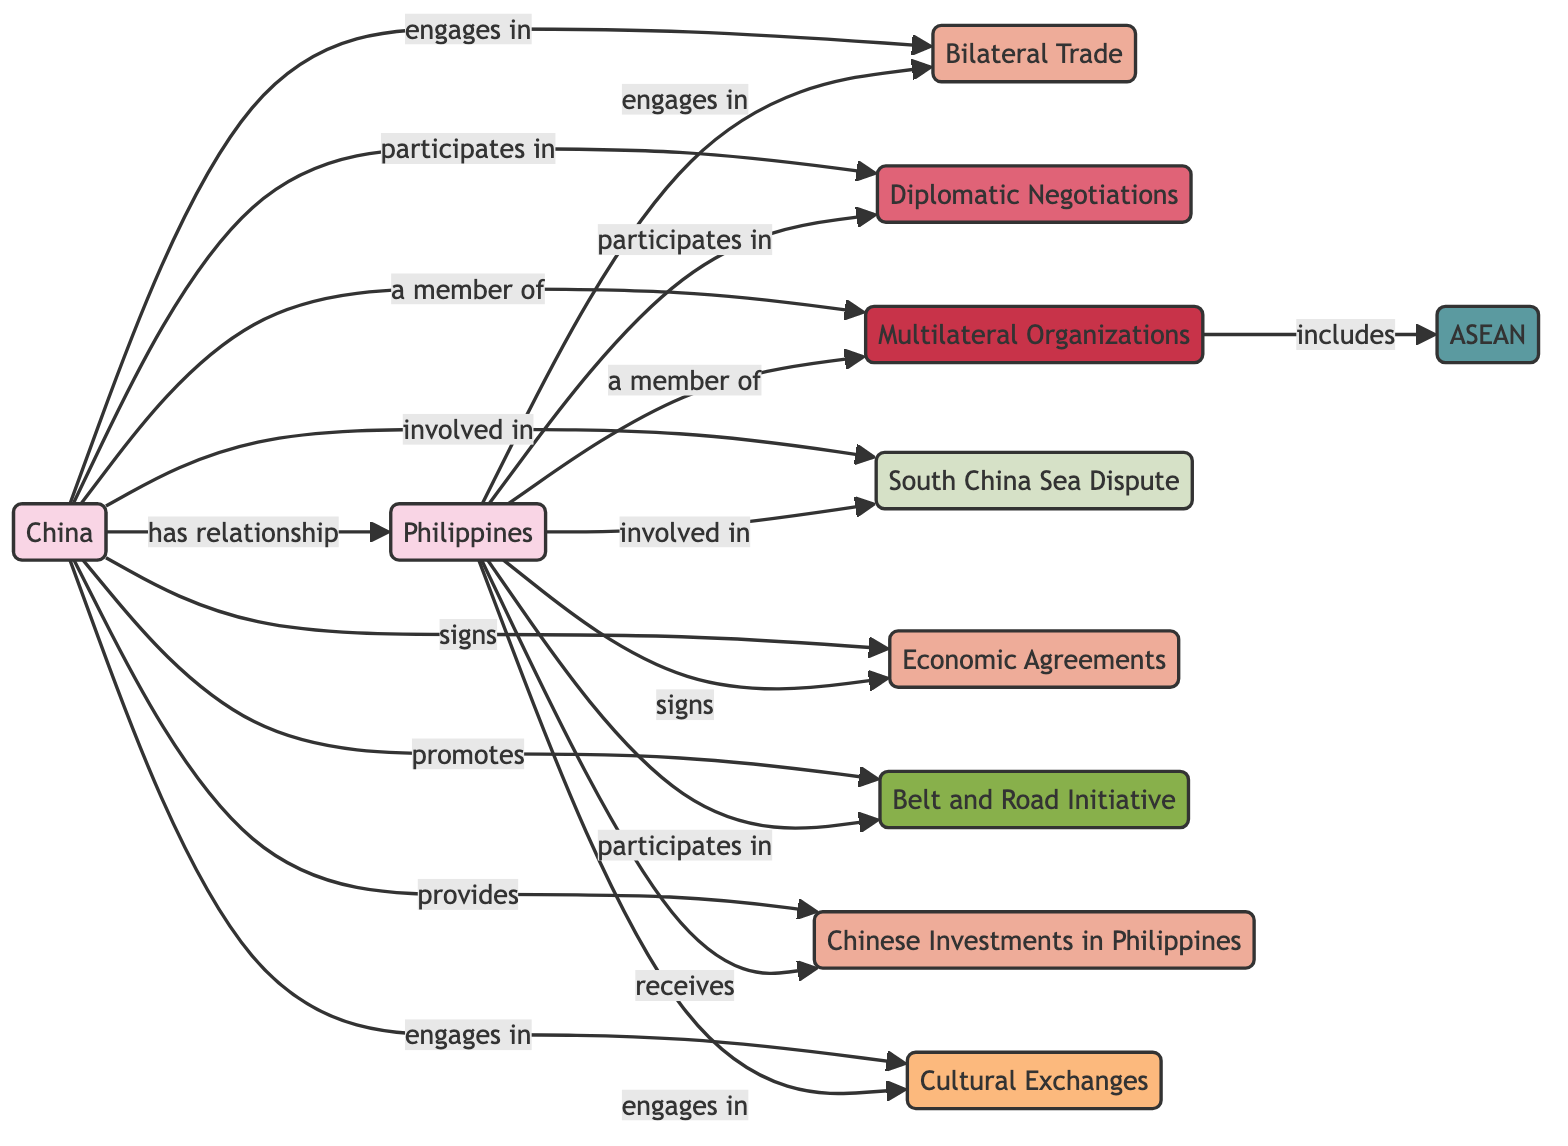What are the two countries represented in the diagram? The diagram includes nodes for both "China" and "Philippines," which are the two countries being represented.
Answer: China, Philippines How many economic nodes are present in the diagram? The diagram shows economic nodes: "Bilateral Trade," "Economic Agreements," "Chinese Investments in Philippines," which adds up to three economic nodes.
Answer: 3 Which node is involved in the South China Sea dispute? Both "China" and "Philippines" are involved in the "South China Sea Dispute," as indicated by the connections in the diagram for each country towards this node.
Answer: South China Sea Dispute What is the label of the relationship between China and the Philippines? The relationship is labeled as "has relationship," which is indicated in the edge connecting these two nodes in the diagram.
Answer: has relationship How many members are included in the Multilateral Organizations node? The "Multilateral Organizations" node has connections to both "China" and "Philippines," thereby indicating that they both are members; based on the direct connection to "ASEAN," we understand that it is included in this count, so there are two countries.
Answer: 2 What type of initiatives does China promote concerning the Philippines? The diagram indicates that China "promotes" the "Belt and Road Initiative," which is a key program of engagement with the Philippines.
Answer: Belt and Road Initiative Which organization is included as a member of the Multilateral Organizations? The edge connecting "Multilateral Organizations" to "ASEAN" explicitly indicates that ASEAN is included as a member of that node.
Answer: ASEAN What kind of exchanges do both countries engage in? The diagram shows that both "China" and "Philippines" engage in "Cultural Exchanges," as represented by their connections to this social node.
Answer: Cultural Exchanges What is the action represented by China towards Economic Agreements? The relationship marked in the diagram indicates that China "signs" Economic Agreements, which is a critical aspect of their bilateral trade relations with the Philippines.
Answer: signs 